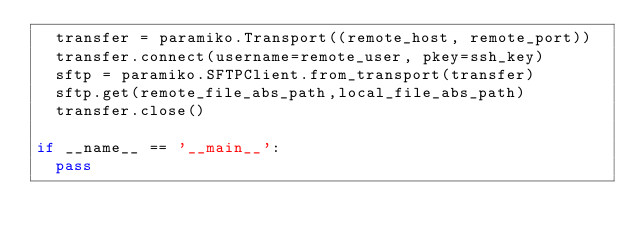<code> <loc_0><loc_0><loc_500><loc_500><_Python_>	transfer = paramiko.Transport((remote_host, remote_port))
	transfer.connect(username=remote_user, pkey=ssh_key)
	sftp = paramiko.SFTPClient.from_transport(transfer)
	sftp.get(remote_file_abs_path,local_file_abs_path)
	transfer.close()

if __name__ == '__main__':
	pass




</code> 